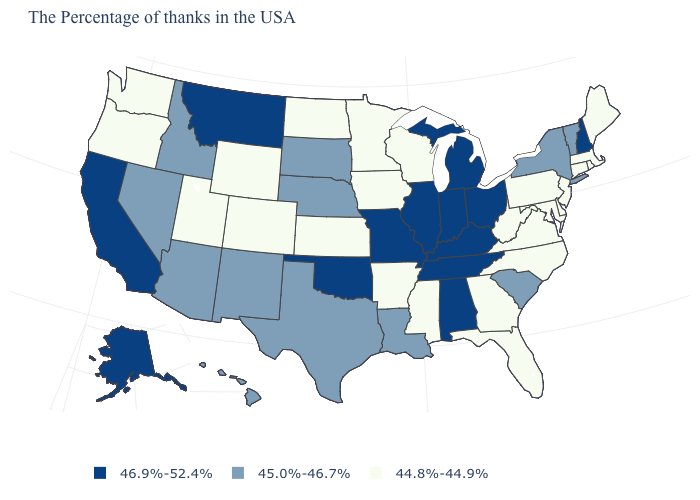Does Wyoming have the lowest value in the West?
Answer briefly. Yes. What is the value of Connecticut?
Give a very brief answer. 44.8%-44.9%. Among the states that border California , which have the lowest value?
Short answer required. Oregon. Among the states that border Idaho , which have the highest value?
Quick response, please. Montana. What is the highest value in the West ?
Quick response, please. 46.9%-52.4%. What is the highest value in states that border Vermont?
Quick response, please. 46.9%-52.4%. What is the value of Wyoming?
Be succinct. 44.8%-44.9%. What is the value of Massachusetts?
Answer briefly. 44.8%-44.9%. Which states have the highest value in the USA?
Be succinct. New Hampshire, Ohio, Michigan, Kentucky, Indiana, Alabama, Tennessee, Illinois, Missouri, Oklahoma, Montana, California, Alaska. Name the states that have a value in the range 45.0%-46.7%?
Concise answer only. Vermont, New York, South Carolina, Louisiana, Nebraska, Texas, South Dakota, New Mexico, Arizona, Idaho, Nevada, Hawaii. What is the highest value in the MidWest ?
Write a very short answer. 46.9%-52.4%. Among the states that border New Jersey , which have the lowest value?
Write a very short answer. Delaware, Pennsylvania. Does Oklahoma have the lowest value in the South?
Keep it brief. No. What is the value of South Dakota?
Keep it brief. 45.0%-46.7%. Does Maine have the same value as Rhode Island?
Give a very brief answer. Yes. 